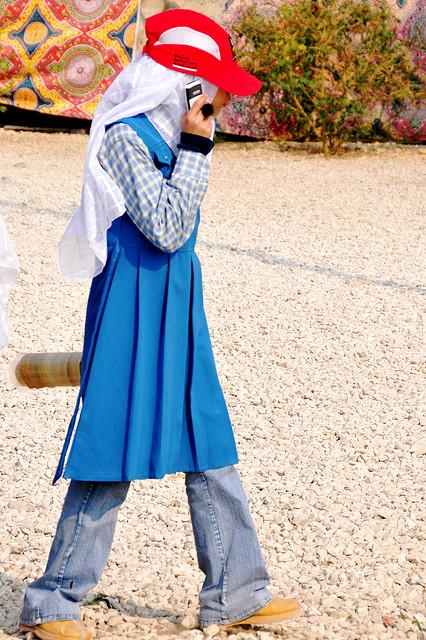Is this person preparing food for dinner?
Quick response, please. No. What is the person wearing?
Answer briefly. Apron. Is this person a man or a woman?
Answer briefly. Woman. 